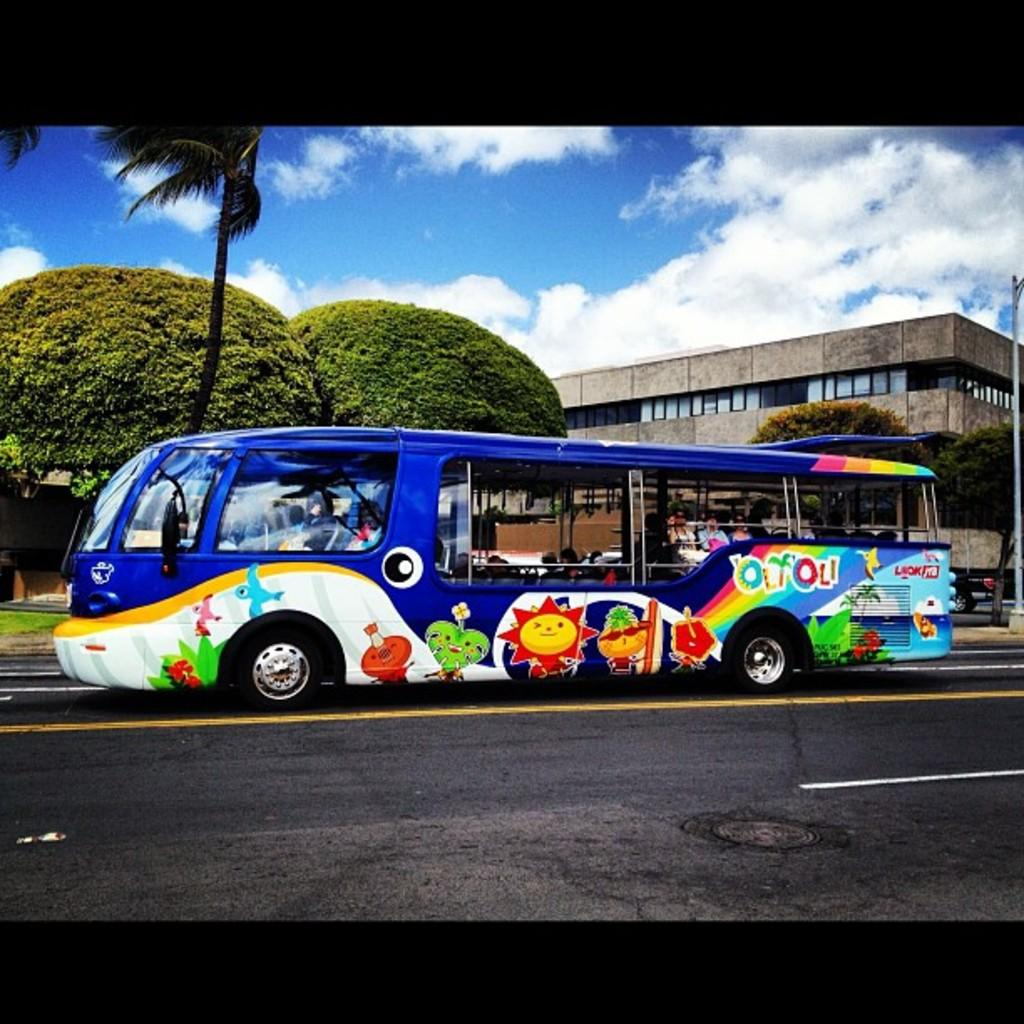Provide a one-sentence caption for the provided image. A very colorful bus with characters painted on it is on a road has the word olyoli written on the side of it. 